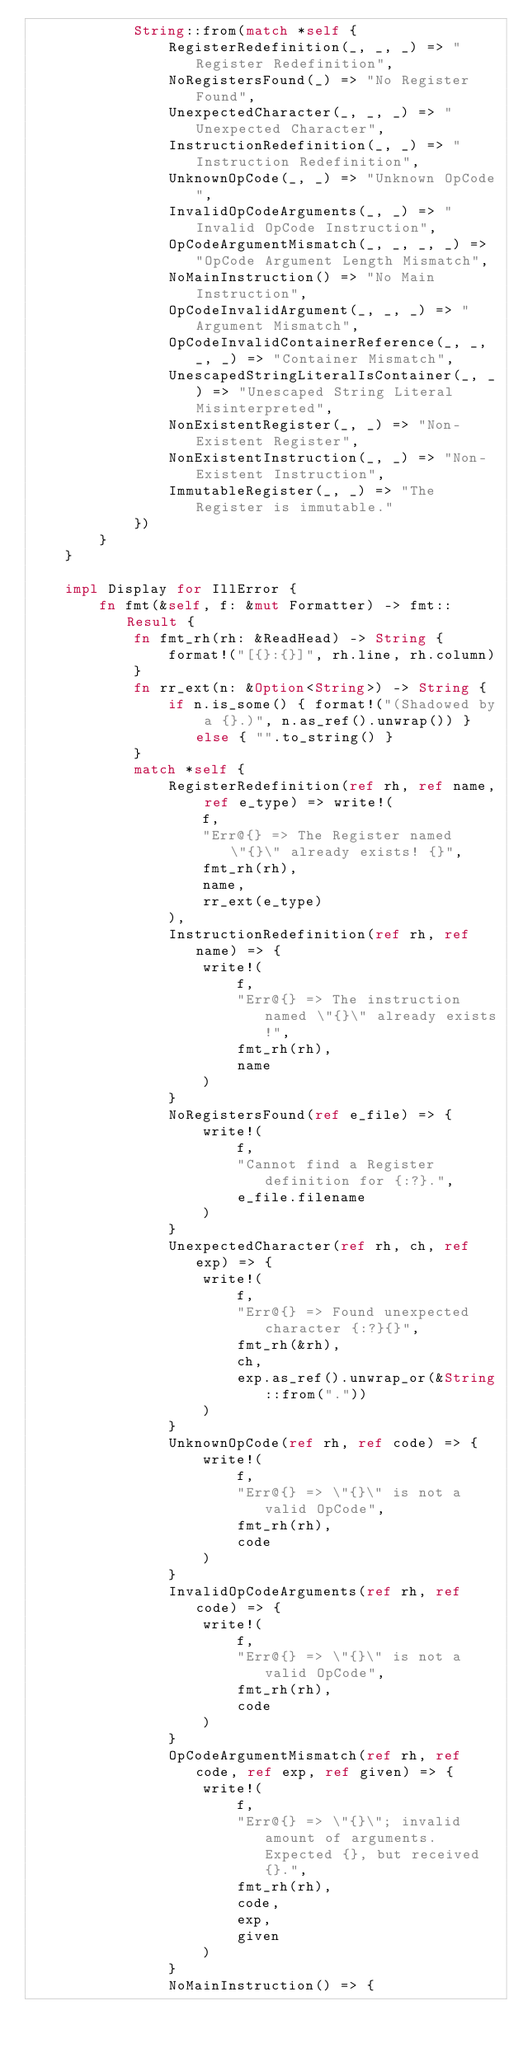<code> <loc_0><loc_0><loc_500><loc_500><_Rust_>            String::from(match *self {
                RegisterRedefinition(_, _, _) => "Register Redefinition",
                NoRegistersFound(_) => "No Register Found",
                UnexpectedCharacter(_, _, _) => "Unexpected Character",
                InstructionRedefinition(_, _) => "Instruction Redefinition",
                UnknownOpCode(_, _) => "Unknown OpCode",
                InvalidOpCodeArguments(_, _) => "Invalid OpCode Instruction",
                OpCodeArgumentMismatch(_, _, _, _) => "OpCode Argument Length Mismatch",
                NoMainInstruction() => "No Main Instruction",
                OpCodeInvalidArgument(_, _, _) => "Argument Mismatch",
                OpCodeInvalidContainerReference(_, _, _, _) => "Container Mismatch",
                UnescapedStringLiteralIsContainer(_, _) => "Unescaped String Literal Misinterpreted",
                NonExistentRegister(_, _) => "Non-Existent Register",
                NonExistentInstruction(_, _) => "Non-Existent Instruction",
                ImmutableRegister(_, _) => "The Register is immutable."
            })
        }
    }

    impl Display for IllError {
        fn fmt(&self, f: &mut Formatter) -> fmt::Result {
            fn fmt_rh(rh: &ReadHead) -> String {
                format!("[{}:{}]", rh.line, rh.column)
            }
            fn rr_ext(n: &Option<String>) -> String {
                if n.is_some() { format!("(Shadowed by a {}.)", n.as_ref().unwrap()) } else { "".to_string() }
            }
            match *self {
                RegisterRedefinition(ref rh, ref name, ref e_type) => write!(
                    f,
                    "Err@{} => The Register named \"{}\" already exists! {}",
                    fmt_rh(rh),
                    name,
                    rr_ext(e_type)
                ),
                InstructionRedefinition(ref rh, ref name) => {
                    write!(
                        f,
                        "Err@{} => The instruction named \"{}\" already exists!",
                        fmt_rh(rh),
                        name
                    )
                }
                NoRegistersFound(ref e_file) => {
                    write!(
                        f,
                        "Cannot find a Register definition for {:?}.",
                        e_file.filename
                    )
                }
                UnexpectedCharacter(ref rh, ch, ref exp) => {
                    write!(
                        f,
                        "Err@{} => Found unexpected character {:?}{}",
                        fmt_rh(&rh),
                        ch,
                        exp.as_ref().unwrap_or(&String::from("."))
                    )
                }
                UnknownOpCode(ref rh, ref code) => {
                    write!(
                        f,
                        "Err@{} => \"{}\" is not a valid OpCode",
                        fmt_rh(rh),
                        code
                    )
                }
                InvalidOpCodeArguments(ref rh, ref code) => {
                    write!(
                        f,
                        "Err@{} => \"{}\" is not a valid OpCode",
                        fmt_rh(rh),
                        code
                    )
                }
                OpCodeArgumentMismatch(ref rh, ref code, ref exp, ref given) => {
                    write!(
                        f,
                        "Err@{} => \"{}\"; invalid amount of arguments. Expected {}, but received {}.",
                        fmt_rh(rh),
                        code,
                        exp,
                        given
                    )
                }
                NoMainInstruction() => {</code> 